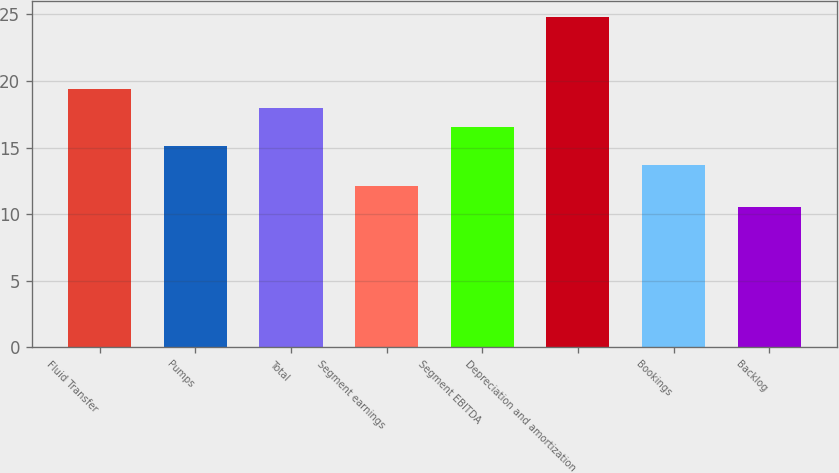Convert chart. <chart><loc_0><loc_0><loc_500><loc_500><bar_chart><fcel>Fluid Transfer<fcel>Pumps<fcel>Total<fcel>Segment earnings<fcel>Segment EBITDA<fcel>Depreciation and amortization<fcel>Bookings<fcel>Backlog<nl><fcel>19.42<fcel>15.13<fcel>17.99<fcel>12.1<fcel>16.56<fcel>24.8<fcel>13.7<fcel>10.5<nl></chart> 